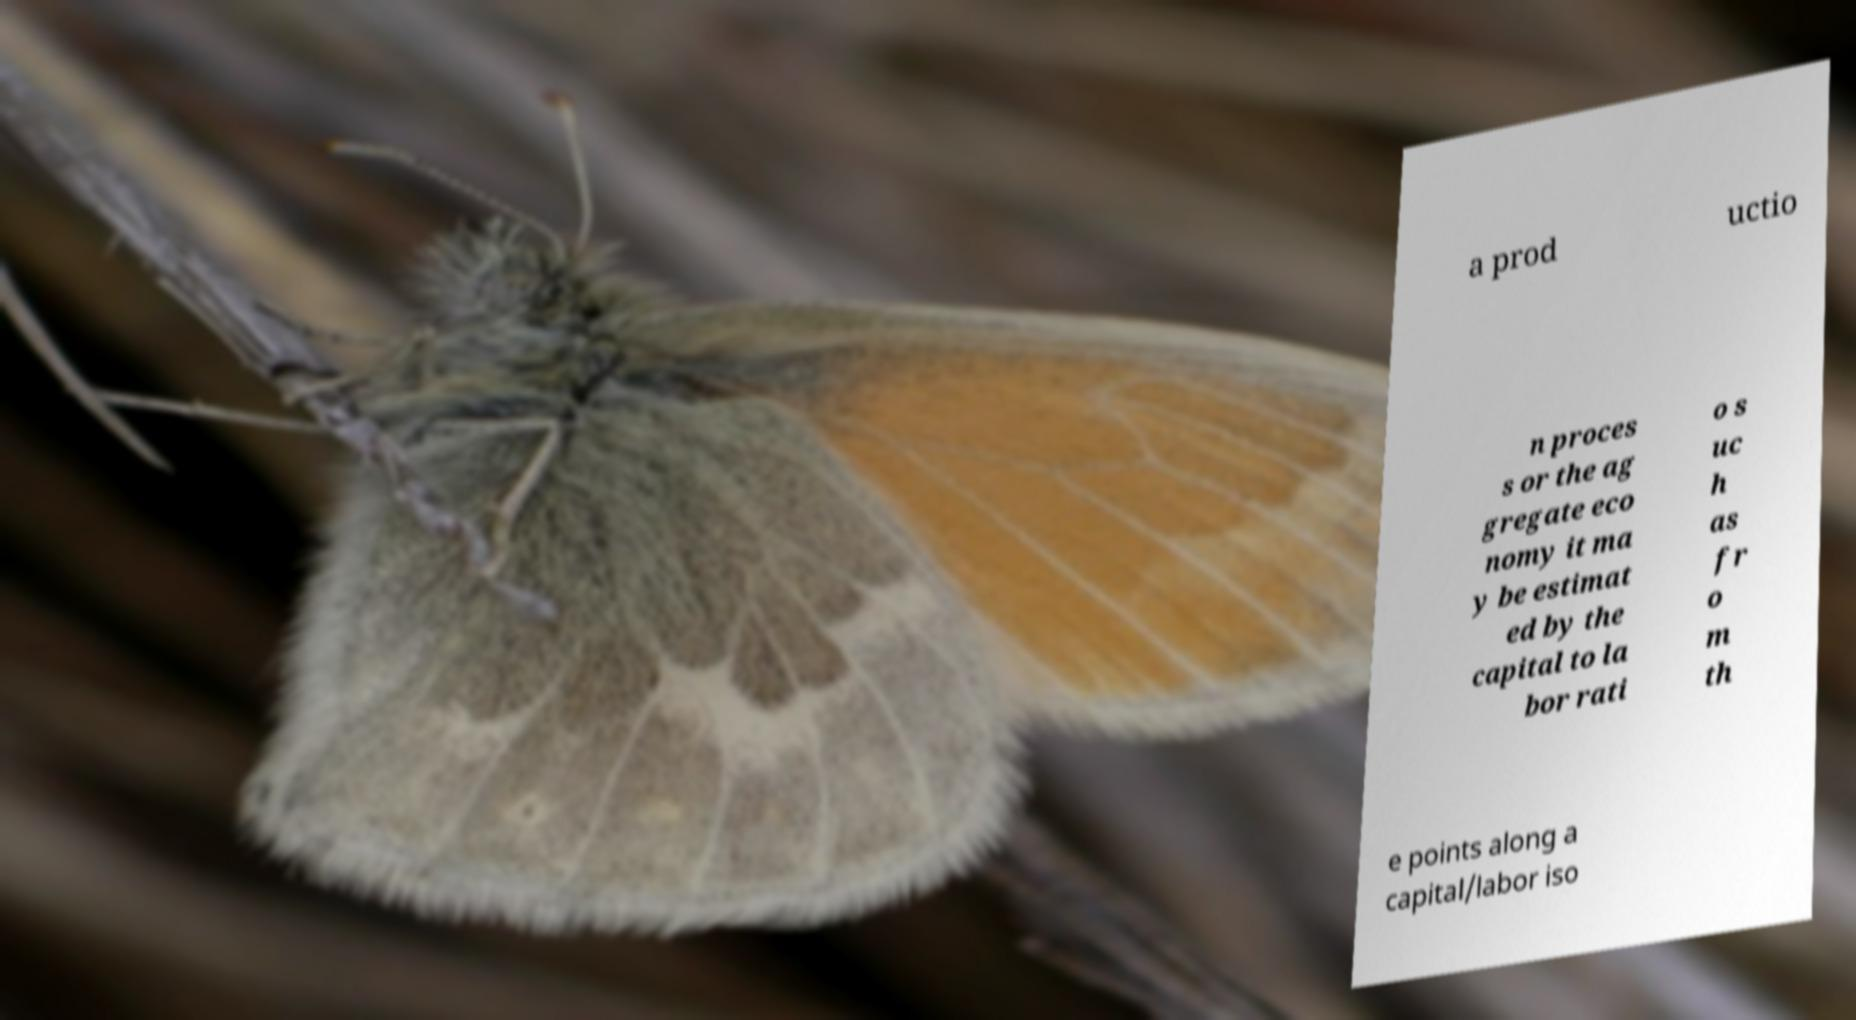There's text embedded in this image that I need extracted. Can you transcribe it verbatim? a prod uctio n proces s or the ag gregate eco nomy it ma y be estimat ed by the capital to la bor rati o s uc h as fr o m th e points along a capital/labor iso 